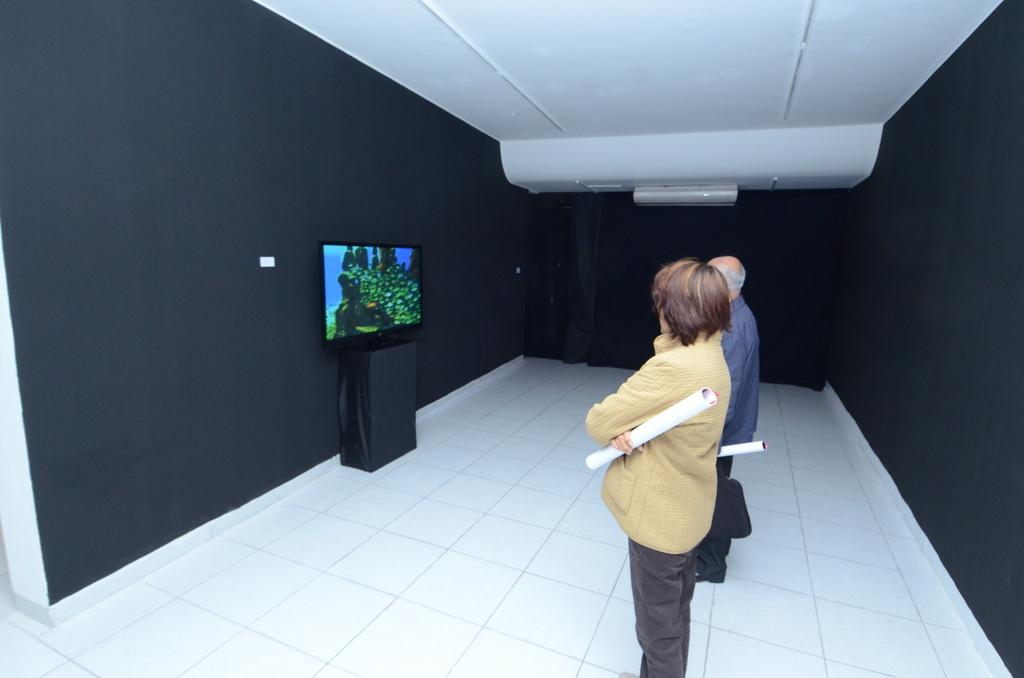How many people are in the image? There are two men in the image. What are the men doing in the image? The men are standing and catching objects with their hands. What object is present on a table in the image? There is a television on a table in the image. What is visible in the background of the image? There is a wall in the image. What type of flower can be seen growing in the alley behind the men in the image? There is no alley or flower present in the image. The men are standing in front of a wall, and no flowers are visible. 